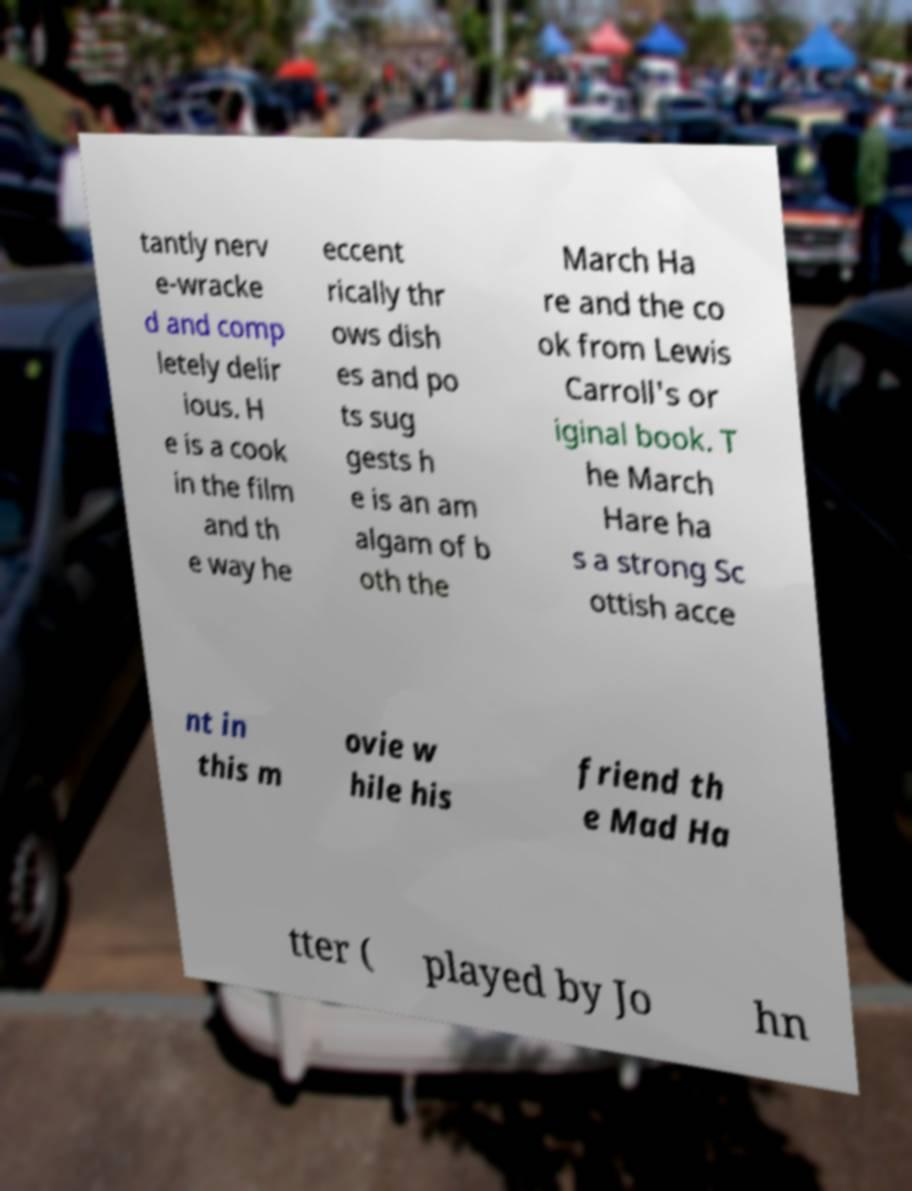Could you assist in decoding the text presented in this image and type it out clearly? tantly nerv e-wracke d and comp letely delir ious. H e is a cook in the film and th e way he eccent rically thr ows dish es and po ts sug gests h e is an am algam of b oth the March Ha re and the co ok from Lewis Carroll's or iginal book. T he March Hare ha s a strong Sc ottish acce nt in this m ovie w hile his friend th e Mad Ha tter ( played by Jo hn 